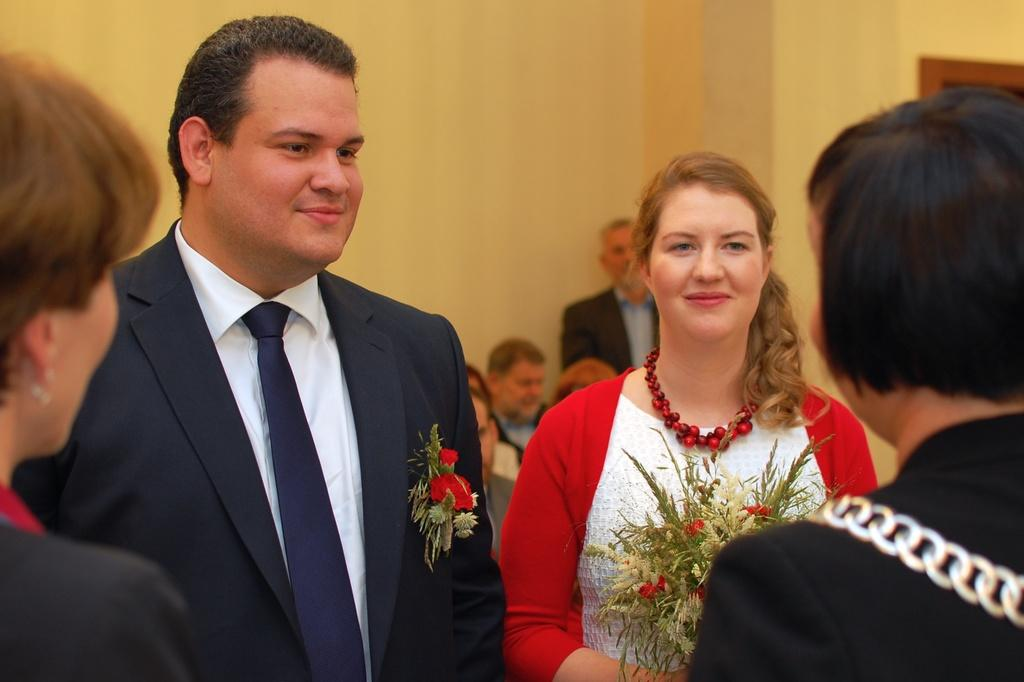Who are the two people in the image? There is a man and a woman standing in the middle of the image. What is the surface they are standing on? They are standing on the floor. What can be seen in the background of the image? There is a wall and persons sitting in the background of the image. What type of ring can be seen on the toad's toes in the image? There is no toad or ring present in the image. 